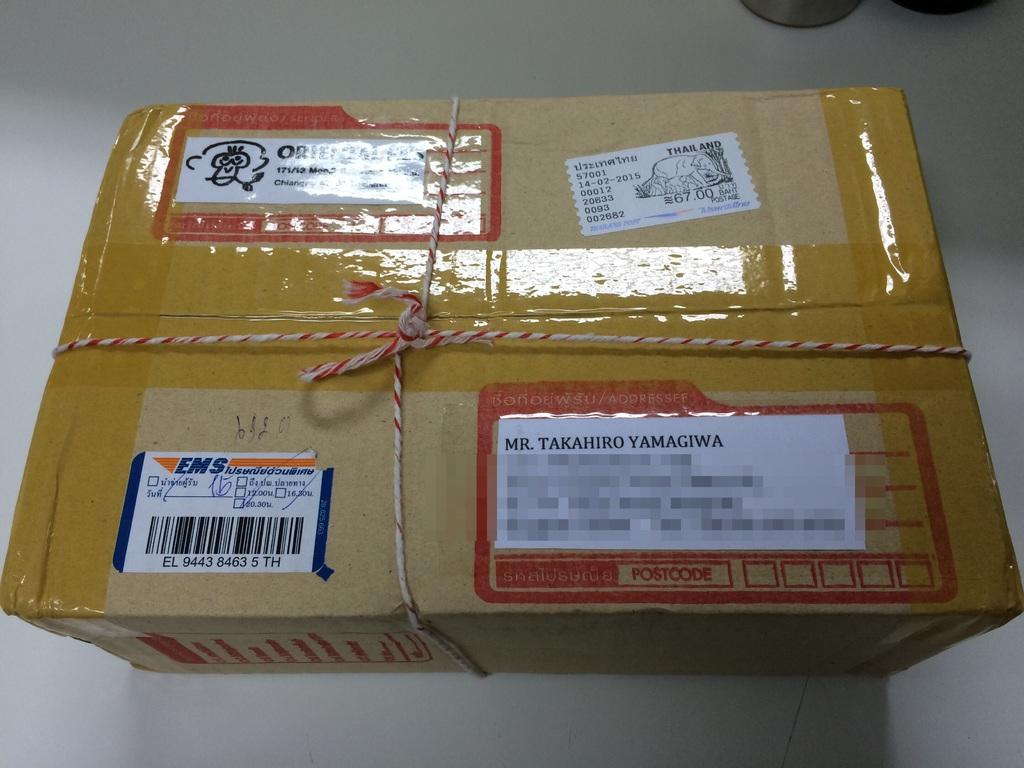<image>
Share a concise interpretation of the image provided. A package to Mr. Takahiro Yamagiwa was mailed from Thailand. 